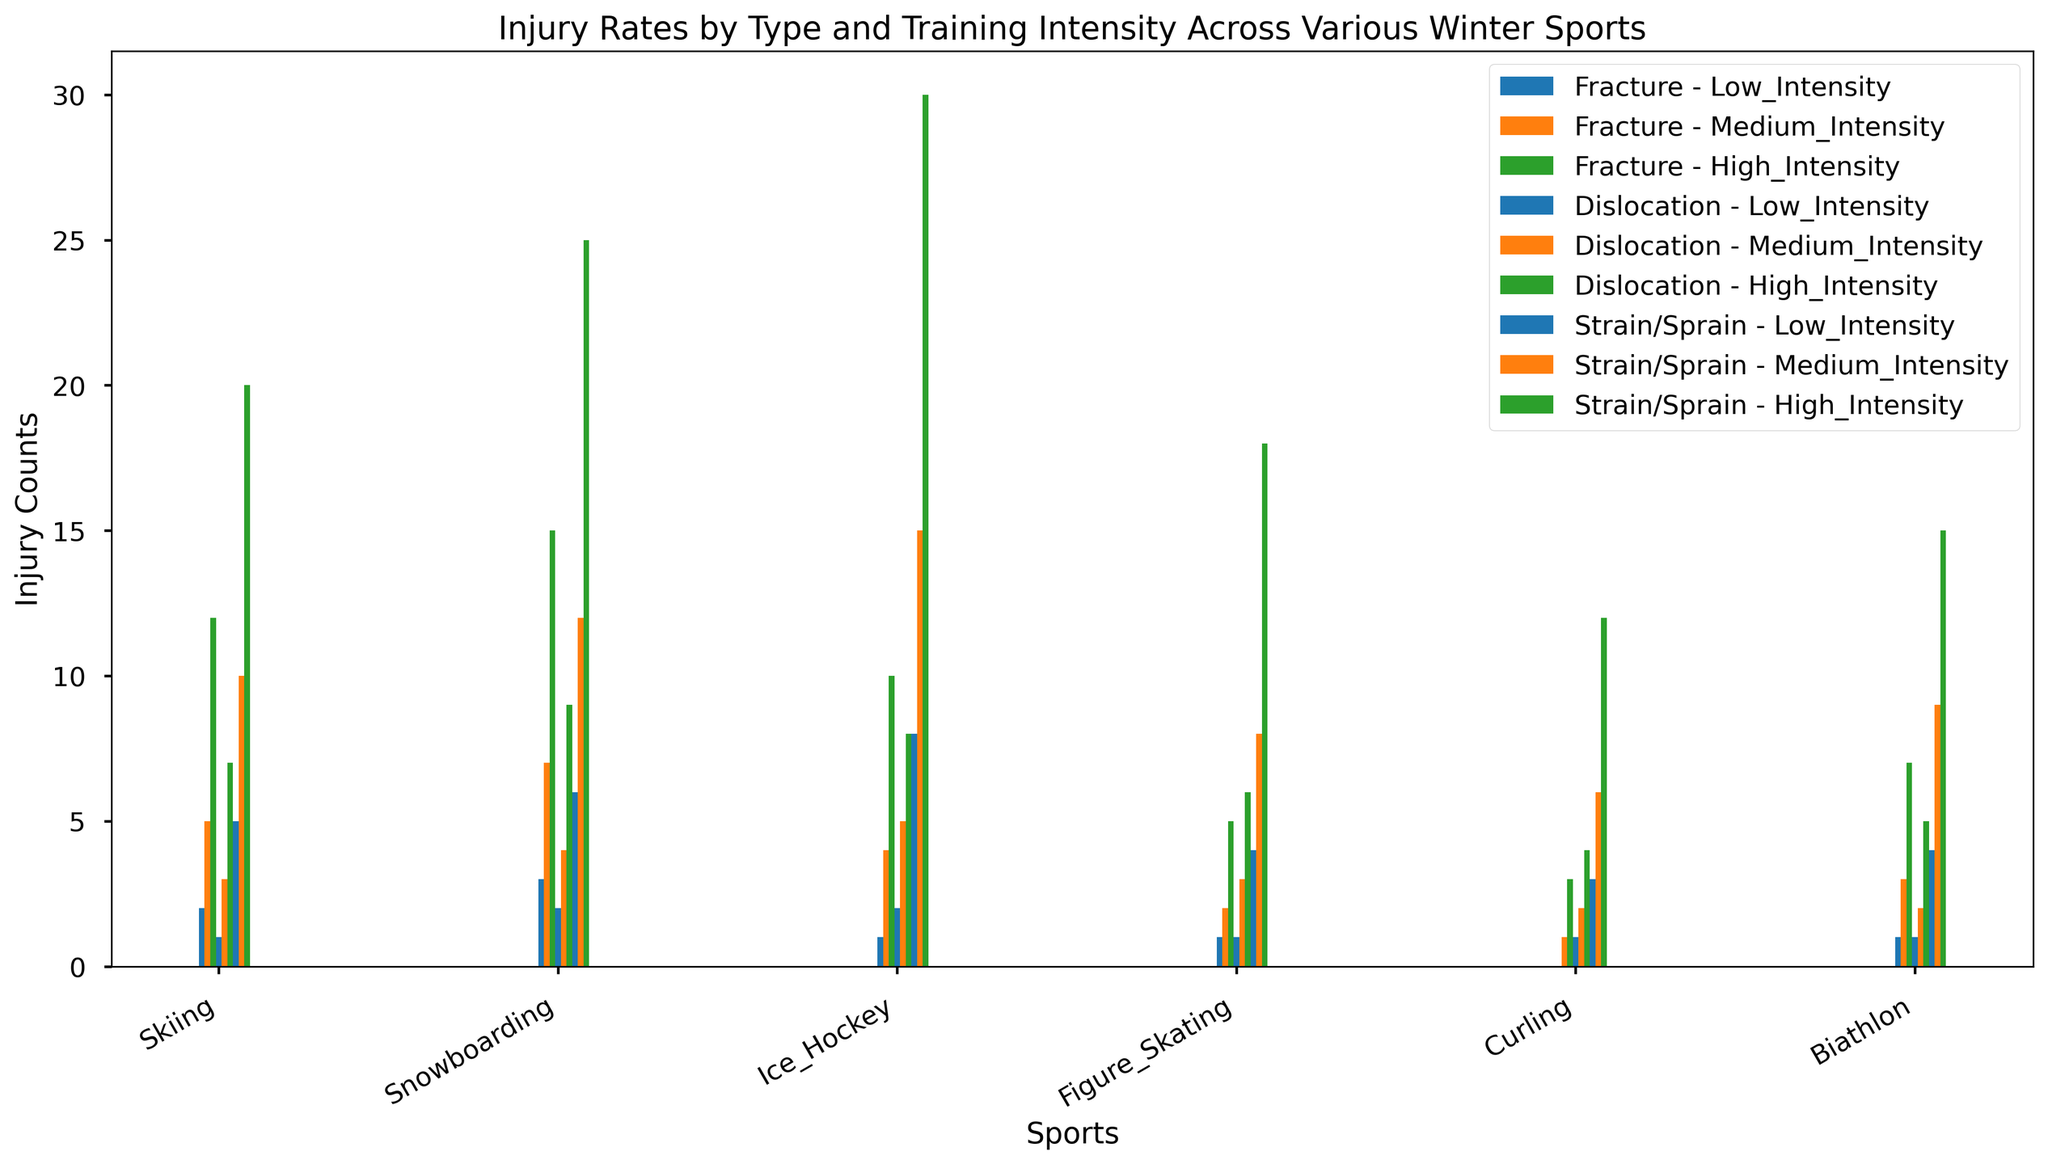Which winter sport has the highest total number of injuries at high intensity? Calculate the sum of all injury types at high intensity for each sport and compare them. Skiing: 12+7+20=39, Snowboarding: 15+9+25=49, Ice Hockey: 10+8+30=48, Figure Skating: 5+6+18=29, Curling: 3+4+12=19, Biathlon: 7+5+15=27. Snowboarding has the highest.
Answer: Snowboarding Which sport has the lowest number of fractures at medium intensity? Compare the heights of the bars representing fractures at medium intensity across all sports. Curling has 1 fracture.
Answer: Curling For dislocations, how many more injuries occur in Ice Hockey at low intensity compared to Curling at high intensity? Find the number of dislocations in Ice Hockey at low intensity (2) and compare it to dislocations in Curling at high intensity (4). The difference is 2 - 4 = -2. So, Curling has 2 more.
Answer: -2 In which sport are strains/sprains at high intensity more than twice the number of strains/sprains at low intensity? Calculate twice the number of strains/sprains at low intensity for each sport and compare it with the number of strains/sprains at high intensity. Skiing: 2*5=10 < 20, Snowboarding: 2*6=12 < 25, Ice Hockey: 2*8=16 < 30, Figure Skating: 2*4=8 < 18, Curling: 2*3=6 < 12, Biathlon: 2*4=8 < 15. All sports meet the criteria.
Answer: All sports Which winter sport has the highest number of fractures at low intensity? Compare the heights of the bars representing fractures at low intensity across all sports. Snowboarding has 3 fractures.
Answer: Snowboarding Which sport has the most evenly distributed number of injuries across all types and intensities? Look for a sport where the bars for each injury type and intensity are relatively close in height. Figure Skating has relatively even distribution of bars across different intensities and injury types.
Answer: Figure Skating Which injury type is most common in Biathlon at medium intensity? Compare the heights of the bars representing different injury types at medium intensity for Biathlon. Strain/Sprain has 9 injuries.
Answer: Strain/Sprain How many more fractures occur in Skiing at high intensity compared to low intensity? Calculate the difference in the number of fractures in Skiing between high intensity (12) and low intensity (2). The difference is 12 - 2 = 10.
Answer: 10 In Snowboarding, how many more strains/sprains are there at high intensity compared to medium intensity? Calculate the difference in the number of strains/sprains in Snowboarding between high intensity (25) and medium intensity (12). The difference is 25 - 12 = 13.
Answer: 13 